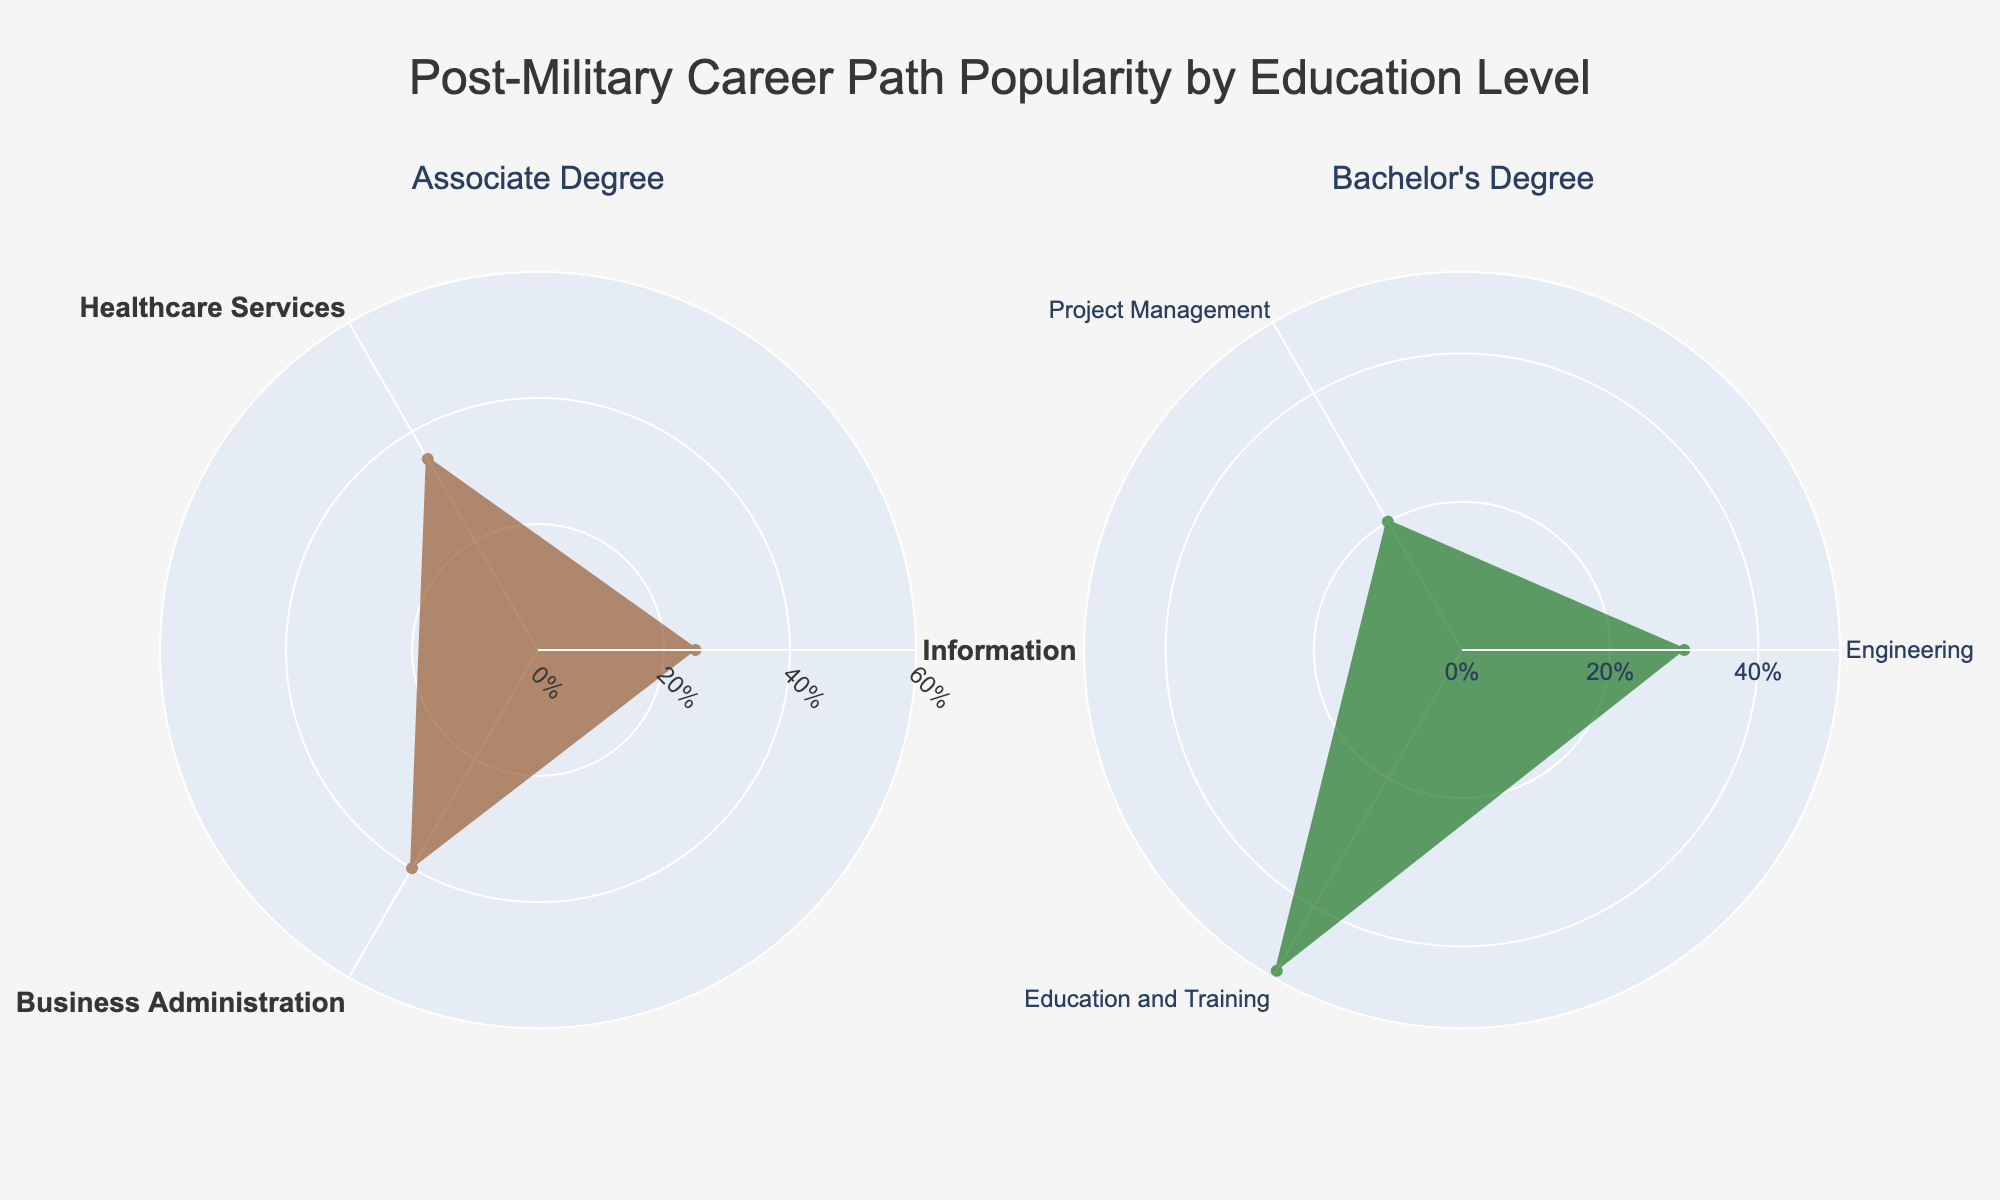what is the title of the figure? The title is shown at the top of the figure and generally provides a summary of what the figure is about. In this case, it is about post-military career path popularity by education level.
Answer: Post-Military Career Path Popularity by Education Level How many education levels are compared in the chart? The figure uses subplots to compare different education levels, with each subplot representing one education level. By counting the subplots, we can determine the number of education levels compared.
Answer: 2 Which career path has the highest popularity percentage for those with a bachelor's degree? Examine the subplot for the bachelor's degree and identify the career path with the longest value from the center, representing the highest percentage.
Answer: Education and Training What is the difference in popularity percentage between Healthcare Services and Business Administration for those with an associate degree? Locate the values for healthcare services (35%) and business administration (40%) in the associate degree subplot and subtract the smaller value from the larger value.
Answer: 5% Which education level has a higher popularity percentage for Information Technology? Compare the values for the Information Technology career path in both subplots representing associate and bachelor's degrees. The longer value indicates higher popularity.
Answer: Associate Degree What is the average popularity percentage of all career paths for a bachelor's degree? Sum the popularity percentages of all career paths under the bachelor's degree subplot (30% + 20% + 50%) and divide by the number of career paths (3).
Answer: 33.33% Do associate degree holders have a higher or lower average career path popularity compared to bachelor’s degree holders? Calculate the average popularity for each education level and compare the two averages. For an associate degree: (25% + 35% + 40%) / 3 = 33.33%. For a bachelor's degree: (30% + 20% + 50%) / 3 = 33.33%. The averages are equal.
Answer: Equal 